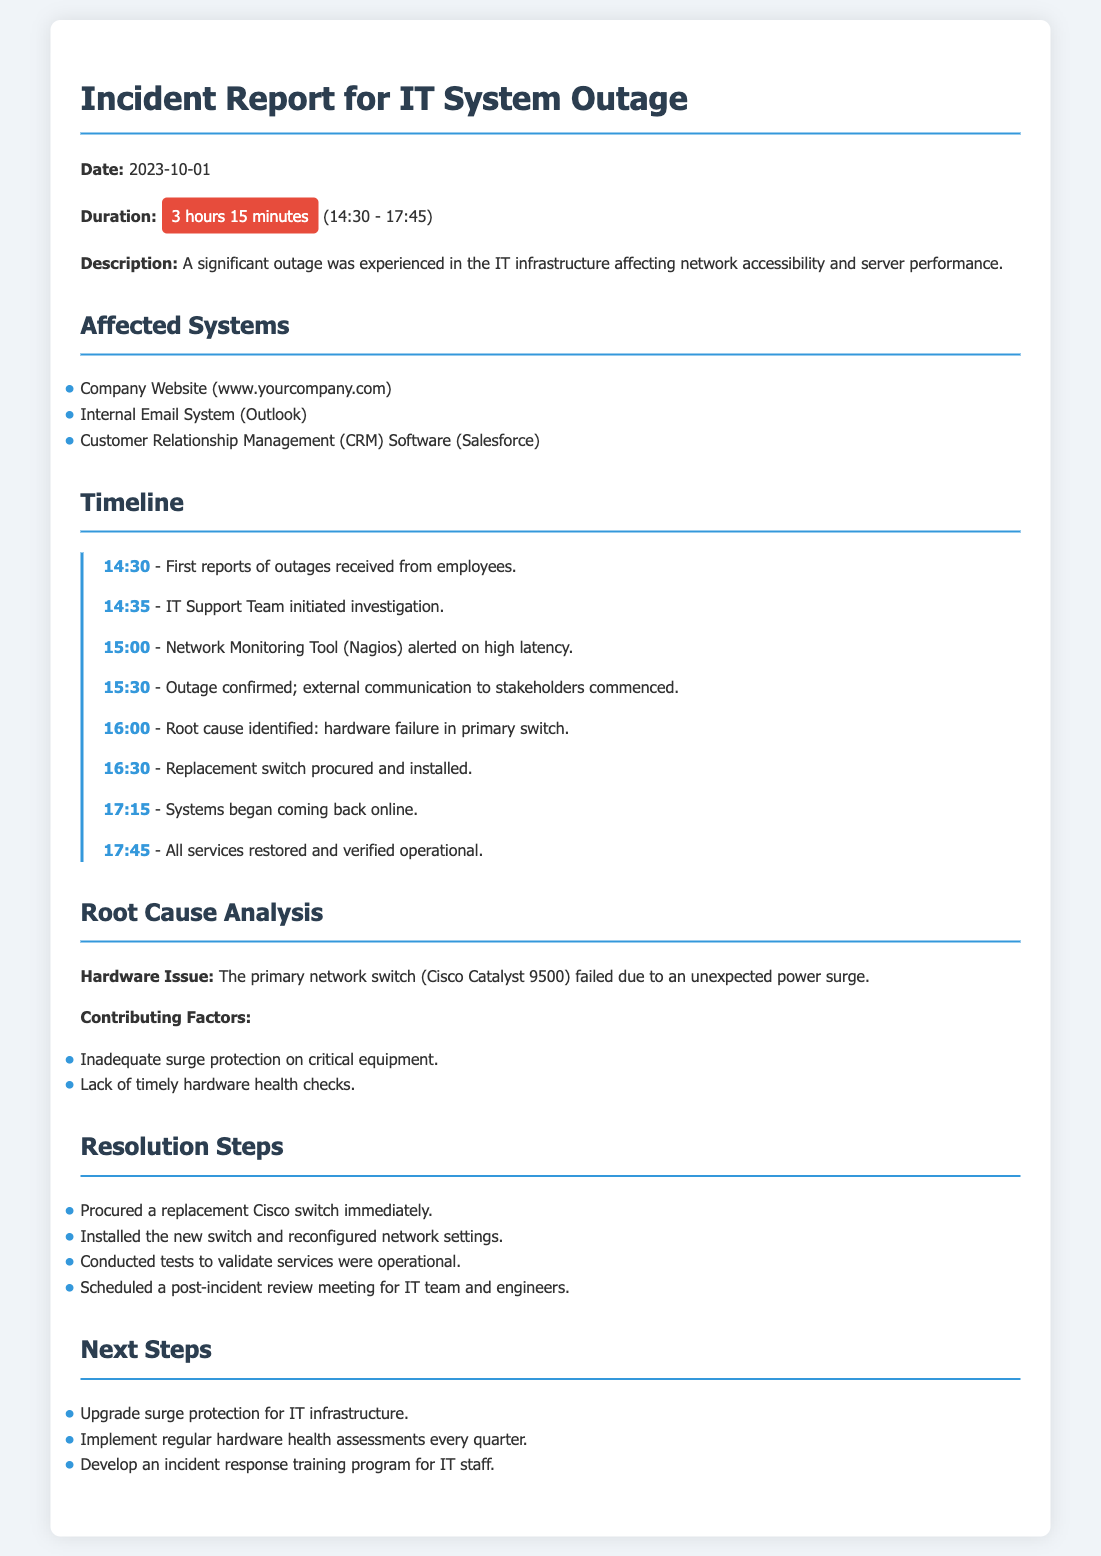What date did the outage occur? The date of the outage is clearly stated in the document as 2023-10-01.
Answer: 2023-10-01 What was the duration of the outage? The document specifies the duration of the outage as 3 hours 15 minutes.
Answer: 3 hours 15 minutes What hardware failed during the incident? The root cause analysis identifies the failed hardware as the primary network switch (Cisco Catalyst 9500).
Answer: Cisco Catalyst 9500 What time was the outage confirmed? The timeline indicates that the outage was confirmed at 15:30.
Answer: 15:30 What was the power issue that contributed to the outage? The document states that the primary network switch failed due to an unexpected power surge.
Answer: power surge What were the steps taken to resolve the outage? The resolution steps include procuring a replacement switch and conducting tests to validate services were operational.
Answer: procured a replacement switch When did all services get restored? The timeline mentions that all services were restored and verified operational at 17:45.
Answer: 17:45 What is one next step mentioned in the document? The next steps include upgrading surge protection for IT infrastructure.
Answer: upgrade surge protection Which software was affected by the outage? The document lists the Customer Relationship Management (CRM) Software as one of the affected systems.
Answer: Salesforce 